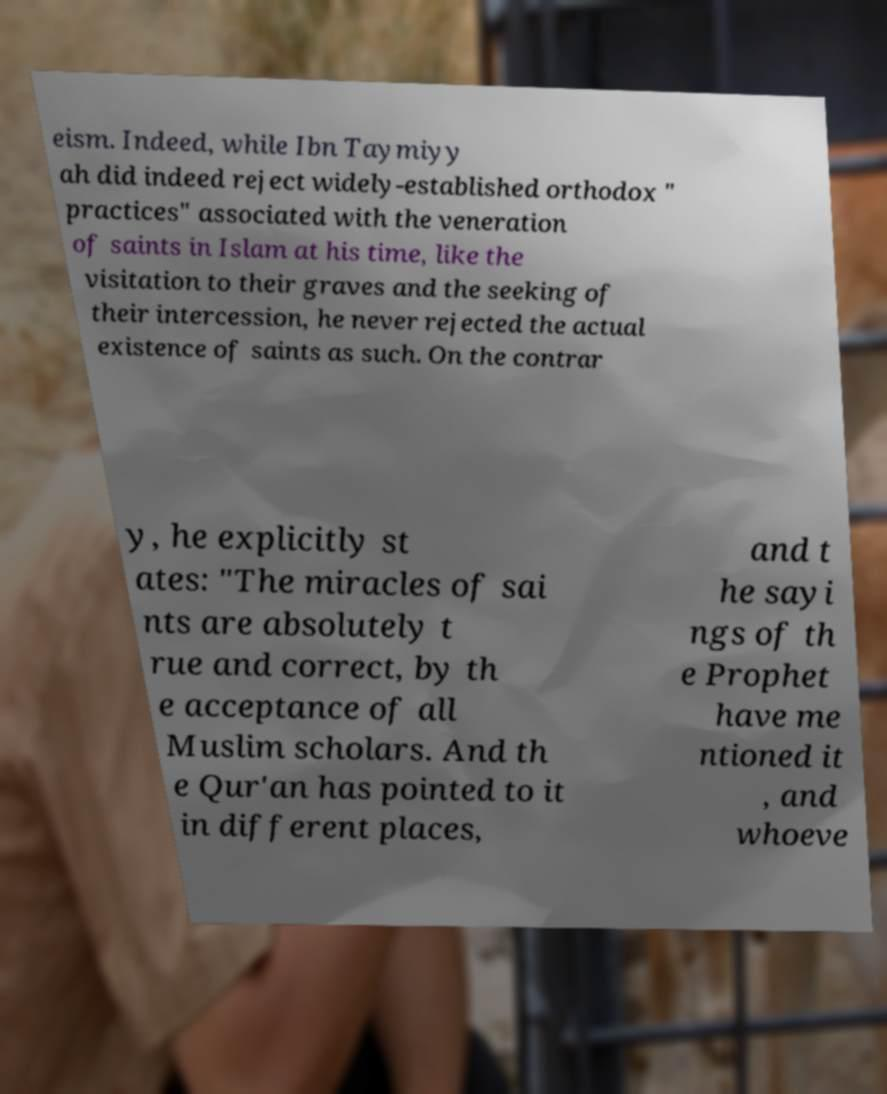I need the written content from this picture converted into text. Can you do that? eism. Indeed, while Ibn Taymiyy ah did indeed reject widely-established orthodox " practices" associated with the veneration of saints in Islam at his time, like the visitation to their graves and the seeking of their intercession, he never rejected the actual existence of saints as such. On the contrar y, he explicitly st ates: "The miracles of sai nts are absolutely t rue and correct, by th e acceptance of all Muslim scholars. And th e Qur'an has pointed to it in different places, and t he sayi ngs of th e Prophet have me ntioned it , and whoeve 